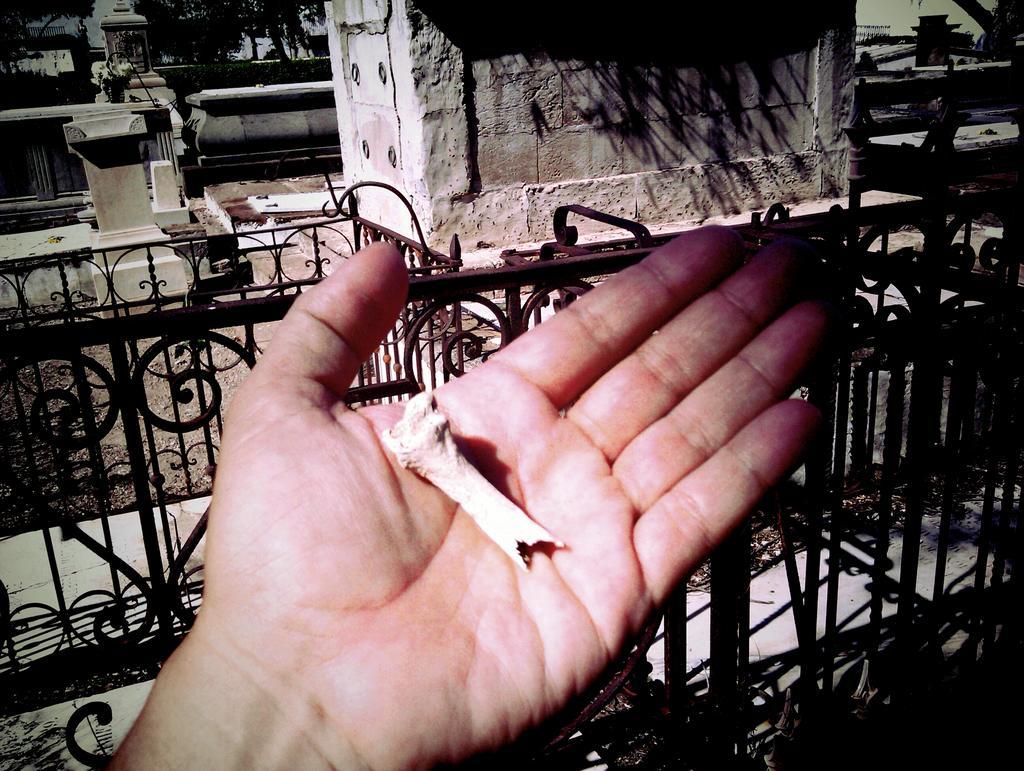In one or two sentences, can you explain what this image depicts? In this picture we can see a person hand and in the background we can see buildings,trees. 